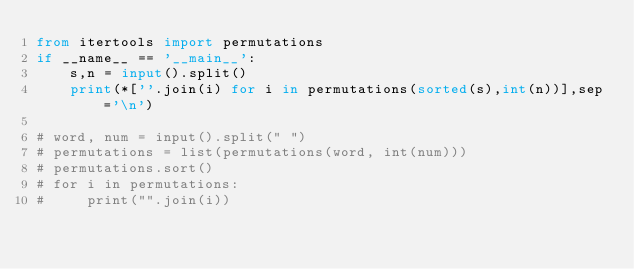Convert code to text. <code><loc_0><loc_0><loc_500><loc_500><_Python_>from itertools import permutations
if __name__ == '__main__':
	s,n = input().split()
	print(*[''.join(i) for i in permutations(sorted(s),int(n))],sep='\n')

# word, num = input().split(" ")
# permutations = list(permutations(word, int(num)))
# permutations.sort()
# for i in permutations:
#     print("".join(i))
</code> 